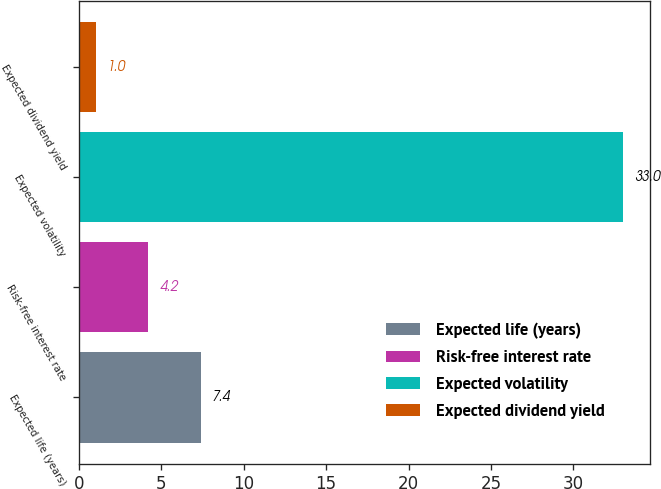Convert chart. <chart><loc_0><loc_0><loc_500><loc_500><bar_chart><fcel>Expected life (years)<fcel>Risk-free interest rate<fcel>Expected volatility<fcel>Expected dividend yield<nl><fcel>7.4<fcel>4.2<fcel>33<fcel>1<nl></chart> 